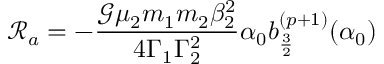Convert formula to latex. <formula><loc_0><loc_0><loc_500><loc_500>\mathcal { R } _ { a } = - \frac { \mathcal { G } \mu _ { 2 } m _ { 1 } m _ { 2 } \beta _ { 2 } ^ { 2 } } { 4 \Gamma _ { 1 } \Gamma _ { 2 } ^ { 2 } } \alpha _ { 0 } b _ { \frac { 3 } { 2 } } ^ { ( p + 1 ) } ( \alpha _ { 0 } )</formula> 